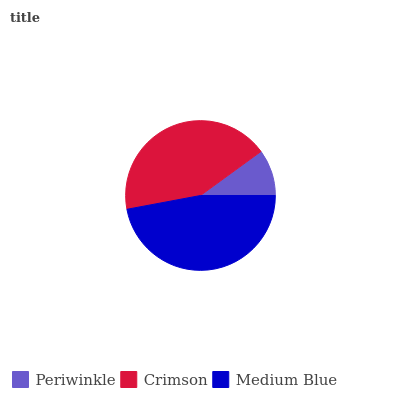Is Periwinkle the minimum?
Answer yes or no. Yes. Is Medium Blue the maximum?
Answer yes or no. Yes. Is Crimson the minimum?
Answer yes or no. No. Is Crimson the maximum?
Answer yes or no. No. Is Crimson greater than Periwinkle?
Answer yes or no. Yes. Is Periwinkle less than Crimson?
Answer yes or no. Yes. Is Periwinkle greater than Crimson?
Answer yes or no. No. Is Crimson less than Periwinkle?
Answer yes or no. No. Is Crimson the high median?
Answer yes or no. Yes. Is Crimson the low median?
Answer yes or no. Yes. Is Periwinkle the high median?
Answer yes or no. No. Is Medium Blue the low median?
Answer yes or no. No. 